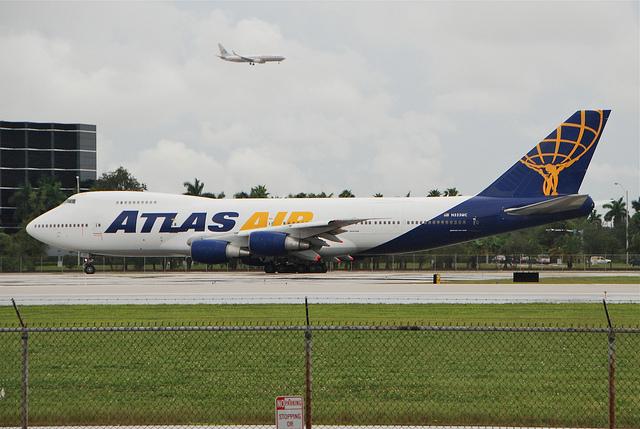How many planes are there?
Keep it brief. 2. Is the bigger airplane in front of the fence?
Answer briefly. No. What color is the aircraft?
Short answer required. White. 